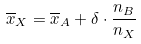Convert formula to latex. <formula><loc_0><loc_0><loc_500><loc_500>\overline { x } _ { X } = \overline { x } _ { A } + \delta \cdot \frac { n _ { B } } { n _ { X } }</formula> 